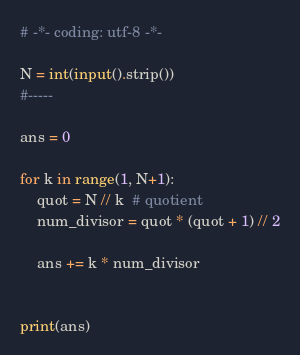<code> <loc_0><loc_0><loc_500><loc_500><_Python_># -*- coding: utf-8 -*-

N = int(input().strip())
#-----

ans = 0

for k in range(1, N+1):
    quot = N // k  # quotient
    num_divisor = quot * (quot + 1) // 2
    
    ans += k * num_divisor


print(ans)
</code> 